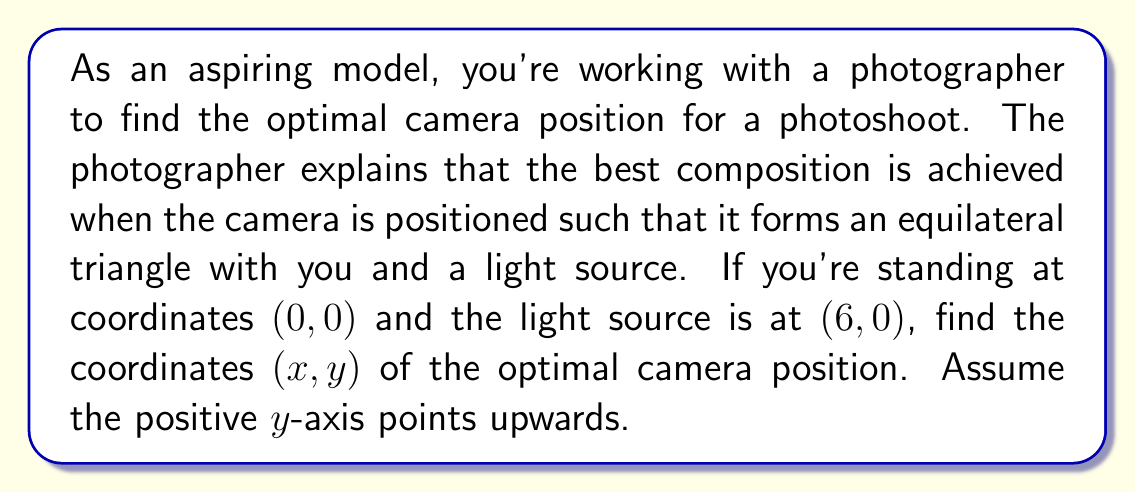Provide a solution to this math problem. Let's approach this step-by-step:

1) An equilateral triangle has all sides equal and all angles equal to 60°.

2) We can use the coordinate system to solve this problem. The model is at (0, 0) and the light source is at (6, 0).

3) Let's call the camera position (x, y). We need to find these coordinates.

4) In an equilateral triangle, the height (h) is related to the side length (s) by the formula:

   $$h = \frac{\sqrt{3}}{2}s$$

5) The distance between the model and the light source is 6 units. This forms the base of our equilateral triangle. So, s = 6.

6) We can now calculate the height:

   $$h = \frac{\sqrt{3}}{2} \cdot 6 = 3\sqrt{3}$$

7) This height is the y-coordinate of the camera position. So, y = $3\sqrt{3}$.

8) For the x-coordinate, we know that the camera should be halfway between the model and the light source horizontally. So:

   $$x = \frac{0 + 6}{2} = 3$$

9) Therefore, the optimal camera position is (3, $3\sqrt{3}$).

[asy]
unitsize(1cm);
pair A = (0,0);
pair B = (6,0);
pair C = (3,3*sqrt(3));
draw(A--B--C--A);
dot("Model (0,0)", A, SW);
dot("Light (6,0)", B, SE);
dot("Camera (3,$3\sqrt{3}$)", C, N);
[/asy]
Answer: The optimal camera position is (3, $3\sqrt{3}$). 